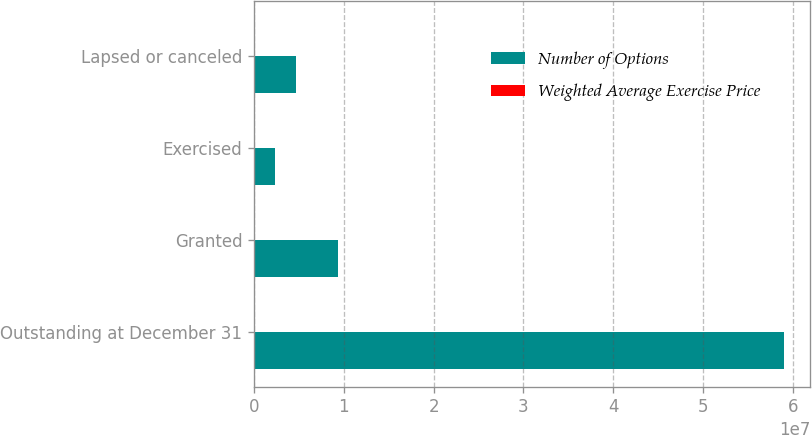Convert chart. <chart><loc_0><loc_0><loc_500><loc_500><stacked_bar_chart><ecel><fcel>Outstanding at December 31<fcel>Granted<fcel>Exercised<fcel>Lapsed or canceled<nl><fcel>Number of Options<fcel>5.89823e+07<fcel>9.37285e+06<fcel>2.36193e+06<fcel>4.73528e+06<nl><fcel>Weighted Average Exercise Price<fcel>38.5<fcel>23.7<fcel>18.34<fcel>39.58<nl></chart> 